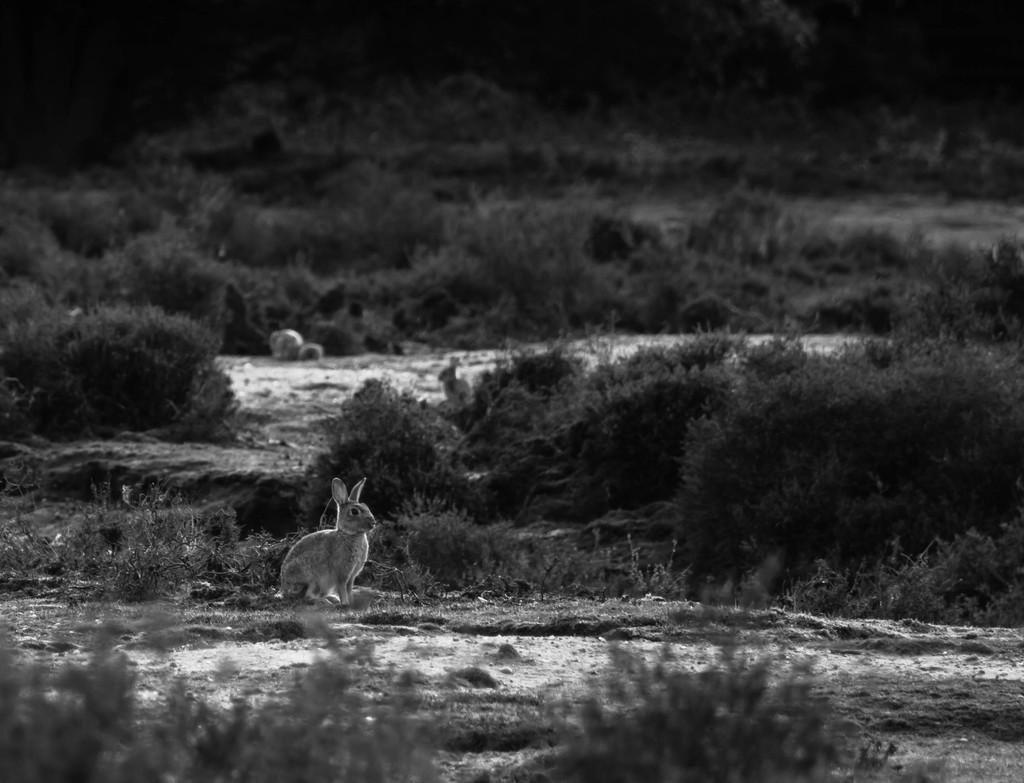What animal can be seen in the image? There is a rabbit in the image. Where is the rabbit located? The rabbit is on the floor. What type of vegetation is present in the image? There are plants, trees, and grass in the image. What is the smell of the river in the image? There is no river present in the image, so it is not possible to determine the smell. 